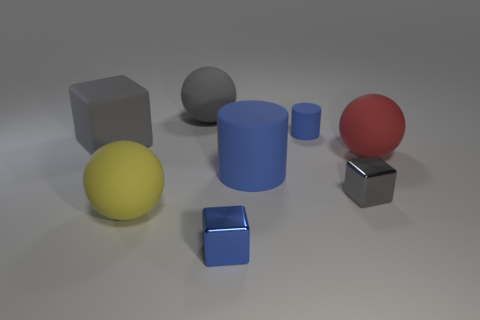What shape is the small metallic object that is the same color as the large rubber cylinder? The small metallic object that shares its color with the large rubber cylinder is a cube. Its clean lines and equal lengths on all edges are the characteristics of a standard cube shape. 